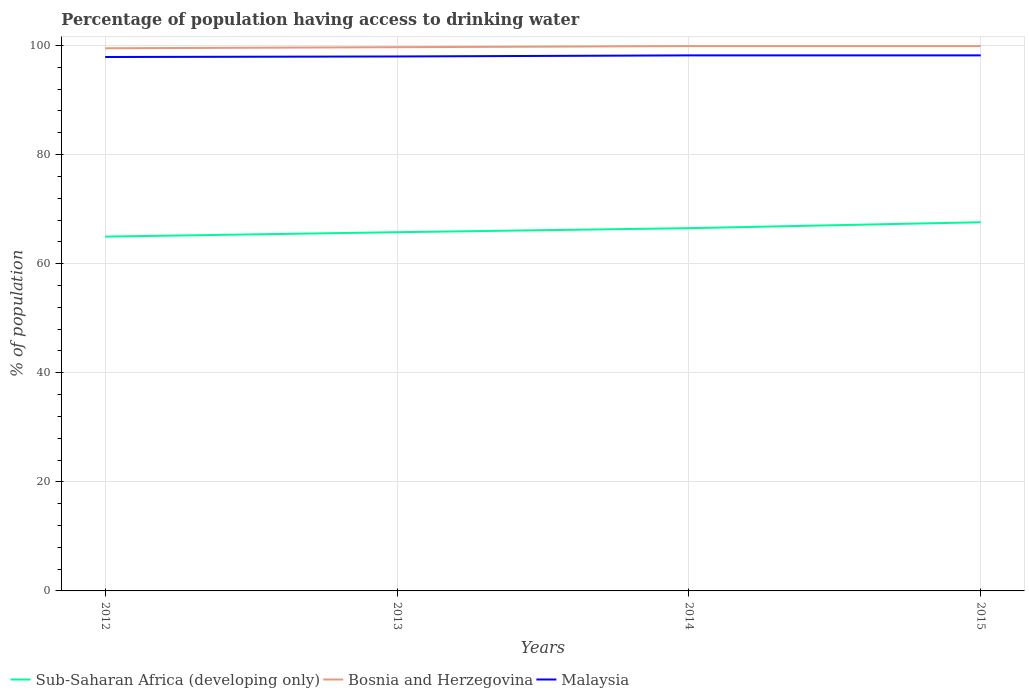Does the line corresponding to Malaysia intersect with the line corresponding to Sub-Saharan Africa (developing only)?
Your answer should be very brief. No. Is the number of lines equal to the number of legend labels?
Provide a succinct answer. Yes. Across all years, what is the maximum percentage of population having access to drinking water in Sub-Saharan Africa (developing only)?
Your answer should be compact. 64.97. In which year was the percentage of population having access to drinking water in Malaysia maximum?
Offer a very short reply. 2012. What is the difference between the highest and the second highest percentage of population having access to drinking water in Sub-Saharan Africa (developing only)?
Your response must be concise. 2.63. How many lines are there?
Your answer should be very brief. 3. What is the difference between two consecutive major ticks on the Y-axis?
Provide a succinct answer. 20. Does the graph contain grids?
Keep it short and to the point. Yes. Where does the legend appear in the graph?
Give a very brief answer. Bottom left. What is the title of the graph?
Keep it short and to the point. Percentage of population having access to drinking water. What is the label or title of the X-axis?
Offer a terse response. Years. What is the label or title of the Y-axis?
Make the answer very short. % of population. What is the % of population of Sub-Saharan Africa (developing only) in 2012?
Offer a terse response. 64.97. What is the % of population in Bosnia and Herzegovina in 2012?
Make the answer very short. 99.5. What is the % of population of Malaysia in 2012?
Your answer should be compact. 97.9. What is the % of population in Sub-Saharan Africa (developing only) in 2013?
Your answer should be compact. 65.77. What is the % of population in Bosnia and Herzegovina in 2013?
Your answer should be very brief. 99.7. What is the % of population in Malaysia in 2013?
Provide a succinct answer. 98. What is the % of population in Sub-Saharan Africa (developing only) in 2014?
Your answer should be compact. 66.52. What is the % of population of Bosnia and Herzegovina in 2014?
Provide a succinct answer. 99.9. What is the % of population in Malaysia in 2014?
Keep it short and to the point. 98.2. What is the % of population of Sub-Saharan Africa (developing only) in 2015?
Offer a terse response. 67.6. What is the % of population of Bosnia and Herzegovina in 2015?
Your answer should be compact. 99.9. What is the % of population of Malaysia in 2015?
Your answer should be compact. 98.2. Across all years, what is the maximum % of population in Sub-Saharan Africa (developing only)?
Make the answer very short. 67.6. Across all years, what is the maximum % of population in Bosnia and Herzegovina?
Give a very brief answer. 99.9. Across all years, what is the maximum % of population in Malaysia?
Give a very brief answer. 98.2. Across all years, what is the minimum % of population in Sub-Saharan Africa (developing only)?
Provide a succinct answer. 64.97. Across all years, what is the minimum % of population in Bosnia and Herzegovina?
Give a very brief answer. 99.5. Across all years, what is the minimum % of population of Malaysia?
Provide a short and direct response. 97.9. What is the total % of population in Sub-Saharan Africa (developing only) in the graph?
Provide a short and direct response. 264.86. What is the total % of population in Bosnia and Herzegovina in the graph?
Offer a terse response. 399. What is the total % of population of Malaysia in the graph?
Give a very brief answer. 392.3. What is the difference between the % of population in Sub-Saharan Africa (developing only) in 2012 and that in 2013?
Provide a short and direct response. -0.81. What is the difference between the % of population in Bosnia and Herzegovina in 2012 and that in 2013?
Offer a very short reply. -0.2. What is the difference between the % of population of Sub-Saharan Africa (developing only) in 2012 and that in 2014?
Keep it short and to the point. -1.55. What is the difference between the % of population of Malaysia in 2012 and that in 2014?
Give a very brief answer. -0.3. What is the difference between the % of population of Sub-Saharan Africa (developing only) in 2012 and that in 2015?
Your answer should be very brief. -2.63. What is the difference between the % of population in Malaysia in 2012 and that in 2015?
Offer a very short reply. -0.3. What is the difference between the % of population of Sub-Saharan Africa (developing only) in 2013 and that in 2014?
Provide a short and direct response. -0.74. What is the difference between the % of population of Malaysia in 2013 and that in 2014?
Make the answer very short. -0.2. What is the difference between the % of population in Sub-Saharan Africa (developing only) in 2013 and that in 2015?
Offer a terse response. -1.83. What is the difference between the % of population in Bosnia and Herzegovina in 2013 and that in 2015?
Keep it short and to the point. -0.2. What is the difference between the % of population of Malaysia in 2013 and that in 2015?
Offer a very short reply. -0.2. What is the difference between the % of population of Sub-Saharan Africa (developing only) in 2014 and that in 2015?
Offer a terse response. -1.09. What is the difference between the % of population of Malaysia in 2014 and that in 2015?
Your answer should be compact. 0. What is the difference between the % of population of Sub-Saharan Africa (developing only) in 2012 and the % of population of Bosnia and Herzegovina in 2013?
Provide a short and direct response. -34.73. What is the difference between the % of population in Sub-Saharan Africa (developing only) in 2012 and the % of population in Malaysia in 2013?
Your answer should be compact. -33.03. What is the difference between the % of population of Bosnia and Herzegovina in 2012 and the % of population of Malaysia in 2013?
Ensure brevity in your answer.  1.5. What is the difference between the % of population in Sub-Saharan Africa (developing only) in 2012 and the % of population in Bosnia and Herzegovina in 2014?
Your answer should be compact. -34.93. What is the difference between the % of population in Sub-Saharan Africa (developing only) in 2012 and the % of population in Malaysia in 2014?
Offer a terse response. -33.23. What is the difference between the % of population in Sub-Saharan Africa (developing only) in 2012 and the % of population in Bosnia and Herzegovina in 2015?
Make the answer very short. -34.93. What is the difference between the % of population in Sub-Saharan Africa (developing only) in 2012 and the % of population in Malaysia in 2015?
Ensure brevity in your answer.  -33.23. What is the difference between the % of population in Sub-Saharan Africa (developing only) in 2013 and the % of population in Bosnia and Herzegovina in 2014?
Give a very brief answer. -34.13. What is the difference between the % of population in Sub-Saharan Africa (developing only) in 2013 and the % of population in Malaysia in 2014?
Your answer should be compact. -32.43. What is the difference between the % of population in Sub-Saharan Africa (developing only) in 2013 and the % of population in Bosnia and Herzegovina in 2015?
Make the answer very short. -34.13. What is the difference between the % of population of Sub-Saharan Africa (developing only) in 2013 and the % of population of Malaysia in 2015?
Offer a terse response. -32.43. What is the difference between the % of population in Sub-Saharan Africa (developing only) in 2014 and the % of population in Bosnia and Herzegovina in 2015?
Offer a terse response. -33.38. What is the difference between the % of population in Sub-Saharan Africa (developing only) in 2014 and the % of population in Malaysia in 2015?
Ensure brevity in your answer.  -31.68. What is the difference between the % of population of Bosnia and Herzegovina in 2014 and the % of population of Malaysia in 2015?
Your answer should be very brief. 1.7. What is the average % of population in Sub-Saharan Africa (developing only) per year?
Provide a short and direct response. 66.22. What is the average % of population of Bosnia and Herzegovina per year?
Provide a short and direct response. 99.75. What is the average % of population in Malaysia per year?
Offer a very short reply. 98.08. In the year 2012, what is the difference between the % of population in Sub-Saharan Africa (developing only) and % of population in Bosnia and Herzegovina?
Make the answer very short. -34.53. In the year 2012, what is the difference between the % of population in Sub-Saharan Africa (developing only) and % of population in Malaysia?
Keep it short and to the point. -32.93. In the year 2012, what is the difference between the % of population in Bosnia and Herzegovina and % of population in Malaysia?
Offer a terse response. 1.6. In the year 2013, what is the difference between the % of population in Sub-Saharan Africa (developing only) and % of population in Bosnia and Herzegovina?
Provide a succinct answer. -33.93. In the year 2013, what is the difference between the % of population of Sub-Saharan Africa (developing only) and % of population of Malaysia?
Provide a succinct answer. -32.23. In the year 2014, what is the difference between the % of population of Sub-Saharan Africa (developing only) and % of population of Bosnia and Herzegovina?
Offer a terse response. -33.38. In the year 2014, what is the difference between the % of population in Sub-Saharan Africa (developing only) and % of population in Malaysia?
Give a very brief answer. -31.68. In the year 2015, what is the difference between the % of population of Sub-Saharan Africa (developing only) and % of population of Bosnia and Herzegovina?
Offer a terse response. -32.3. In the year 2015, what is the difference between the % of population in Sub-Saharan Africa (developing only) and % of population in Malaysia?
Your response must be concise. -30.6. What is the ratio of the % of population of Bosnia and Herzegovina in 2012 to that in 2013?
Provide a short and direct response. 1. What is the ratio of the % of population in Sub-Saharan Africa (developing only) in 2012 to that in 2014?
Make the answer very short. 0.98. What is the ratio of the % of population in Bosnia and Herzegovina in 2012 to that in 2014?
Keep it short and to the point. 1. What is the ratio of the % of population of Sub-Saharan Africa (developing only) in 2013 to that in 2014?
Provide a succinct answer. 0.99. What is the ratio of the % of population of Bosnia and Herzegovina in 2013 to that in 2014?
Your answer should be compact. 1. What is the ratio of the % of population of Sub-Saharan Africa (developing only) in 2013 to that in 2015?
Provide a succinct answer. 0.97. What is the ratio of the % of population of Sub-Saharan Africa (developing only) in 2014 to that in 2015?
Provide a short and direct response. 0.98. What is the ratio of the % of population in Bosnia and Herzegovina in 2014 to that in 2015?
Make the answer very short. 1. What is the ratio of the % of population of Malaysia in 2014 to that in 2015?
Your response must be concise. 1. What is the difference between the highest and the second highest % of population in Sub-Saharan Africa (developing only)?
Provide a succinct answer. 1.09. What is the difference between the highest and the lowest % of population in Sub-Saharan Africa (developing only)?
Keep it short and to the point. 2.63. What is the difference between the highest and the lowest % of population of Bosnia and Herzegovina?
Your answer should be compact. 0.4. 